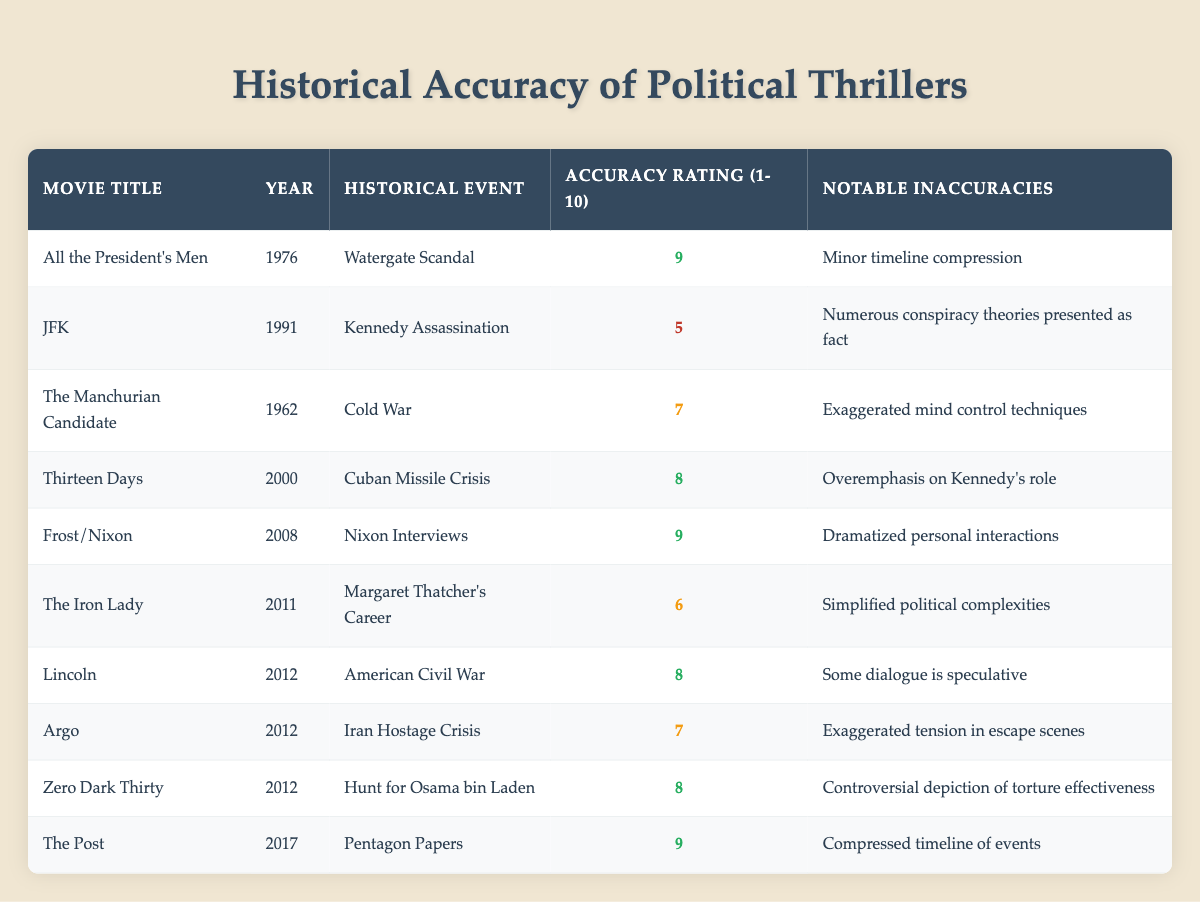What is the title of the movie with the lowest accuracy rating? The table shows the accuracy ratings for each movie. By scanning through the "Accuracy Rating (1-10)" column, "JFK" has the lowest rating of 5.
Answer: JFK Which movie is rated highest for historical accuracy? Looking at the "Accuracy Rating (1-10)" column, "All the President's Men," "Frost/Nixon," and "The Post" all have the highest rating of 9.
Answer: All the President's Men, Frost/Nixon, The Post How many movies from the table were released in 2012? By checking the "Year" column, there are three movies listed for 2012: "Lincoln," "Argo," and "Zero Dark Thirty."
Answer: 3 What is the average accuracy rating of the movies listed? To find the average, add all the accuracy ratings (9 + 5 + 7 + 8 + 9 + 6 + 8 + 7 + 8 + 9 = 76) and divide by the number of movies (10). This results in an average accuracy rating of 76/10 = 7.6.
Answer: 7.6 Did "Thirteen Days" receive a higher accuracy rating than "The Iron Lady"? Comparing the accuracy ratings in the table shows that "Thirteen Days" has a rating of 8 while "The Iron Lady" has a rating of 6, meaning "Thirteen Days" did receive a higher rating.
Answer: Yes What notable inaccuracies are mentioned for "Zero Dark Thirty"? The table lists "Controversial depiction of torture effectiveness" as the notable inaccuracy for "Zero Dark Thirty."
Answer: Controversial depiction of torture effectiveness Which movie has a notable inaccuracy related to "timeline compression"? By reviewing the "Notable Inaccuracies" column, both "All the President's Men" and "The Post" mention timeline compression, but only "All the President's Men" specifically references this issue.
Answer: All the President's Men Is there any movie rated below 6? A quick look through the "Accuracy Rating (1-10)" column reveals that "JFK" has a rating of 5, which is below 6, indicating the answer is yes.
Answer: Yes Which historical event is associated with the movie "Argo"? The table indicates that "Argo" is associated with the "Iran Hostage Crisis."
Answer: Iran Hostage Crisis 